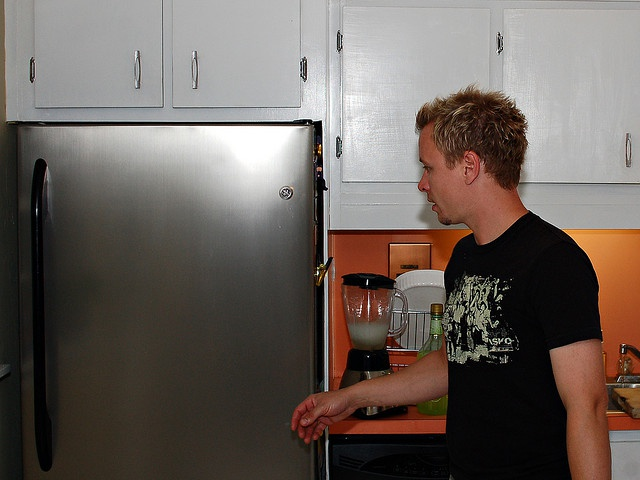Describe the objects in this image and their specific colors. I can see refrigerator in gray, black, lightgray, and darkgray tones, people in gray, black, brown, and maroon tones, bottle in gray, black, darkgreen, and maroon tones, and sink in gray, black, and maroon tones in this image. 